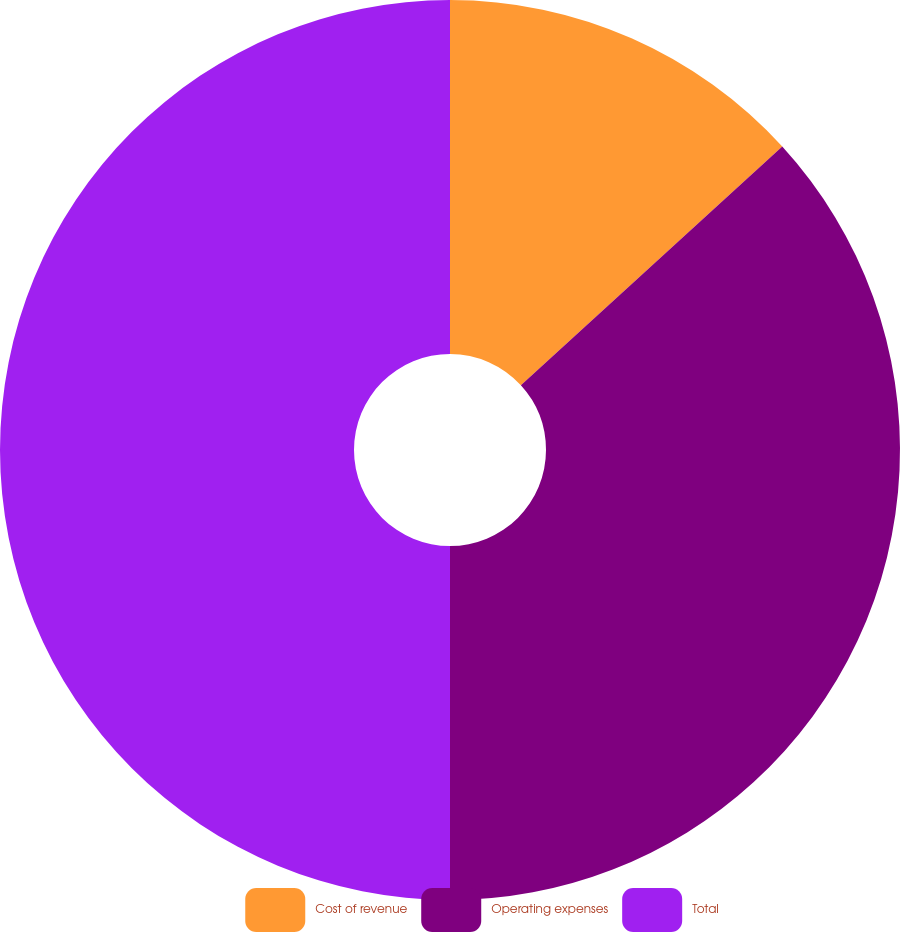Convert chart. <chart><loc_0><loc_0><loc_500><loc_500><pie_chart><fcel>Cost of revenue<fcel>Operating expenses<fcel>Total<nl><fcel>13.22%<fcel>36.78%<fcel>50.0%<nl></chart> 